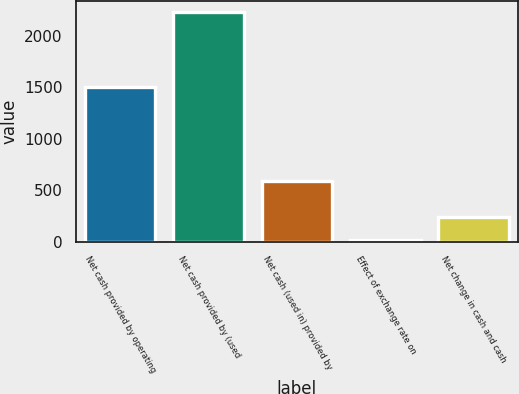<chart> <loc_0><loc_0><loc_500><loc_500><bar_chart><fcel>Net cash provided by operating<fcel>Net cash provided by (used<fcel>Net cash (used in) provided by<fcel>Effect of exchange rate on<fcel>Net change in cash and cash<nl><fcel>1498.1<fcel>2228.7<fcel>593.2<fcel>20.5<fcel>241.32<nl></chart> 